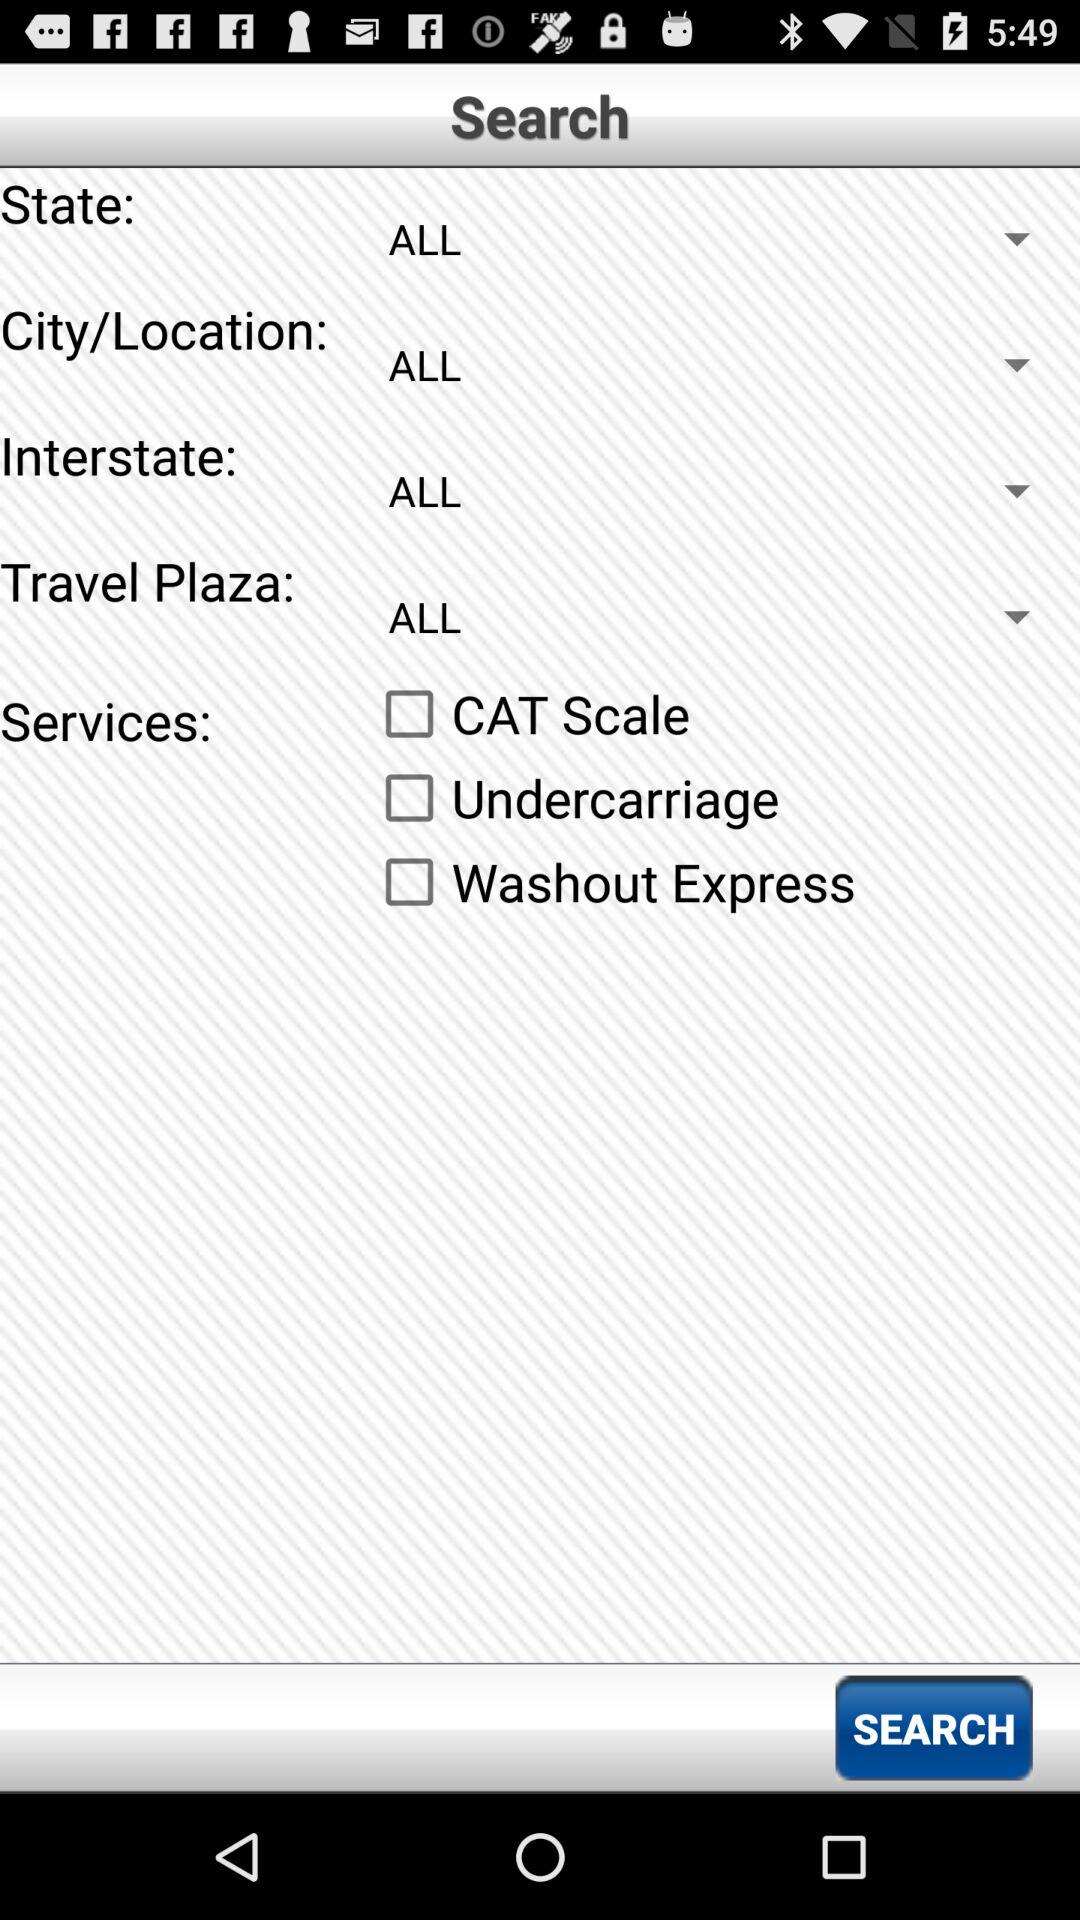What are the available service options? The available service options are "CAT Scale", "Undercarriage" and "Washout Express". 